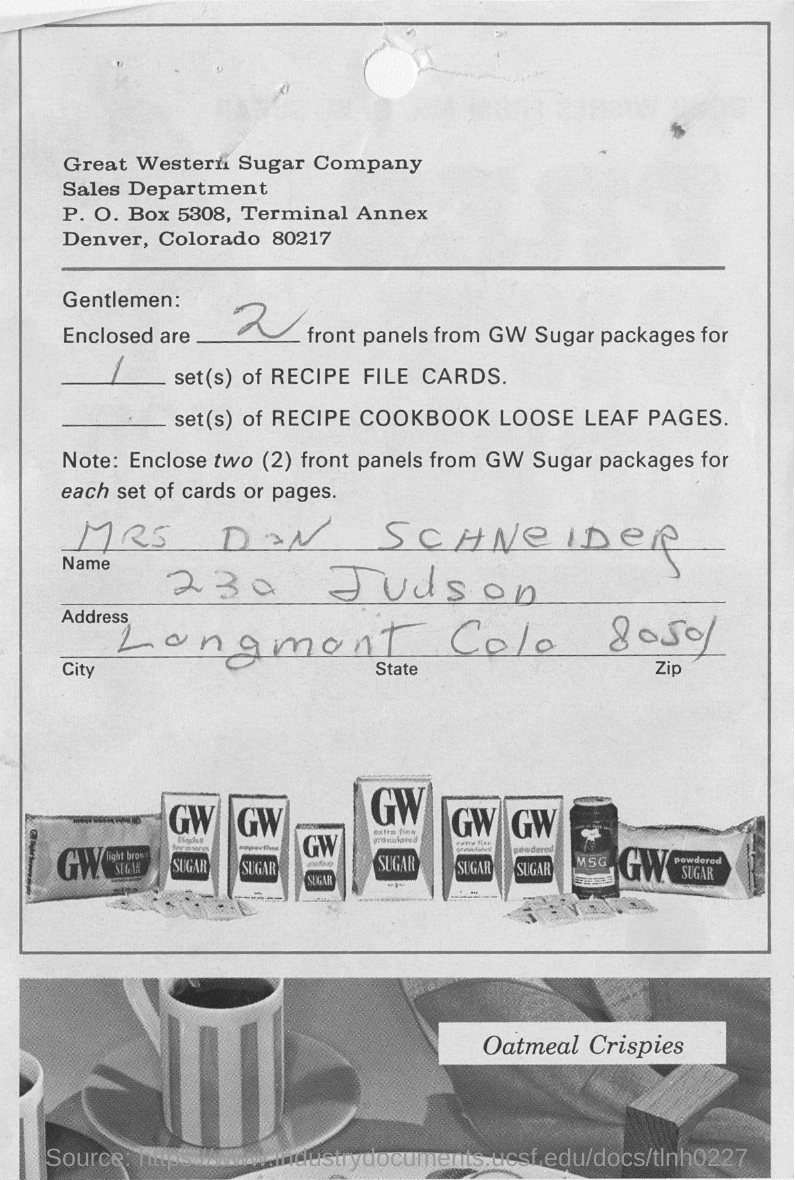Sales department of which company in slip?
Offer a terse response. Great Western Sugar Company. How many front panels are enclosed from gw sugar packages
Offer a terse response. 2. What is the name in the slip?
Your answer should be very brief. Mrs. don Schneider. What kind of meal crispies?
Ensure brevity in your answer.  Oatmeal. 